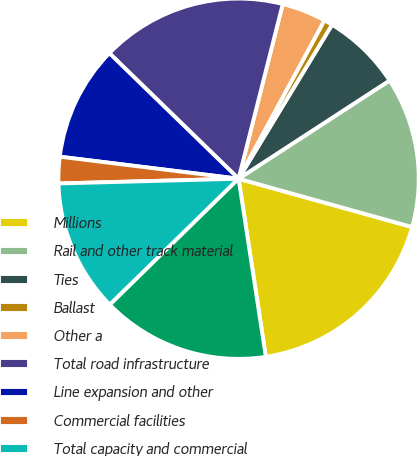Convert chart. <chart><loc_0><loc_0><loc_500><loc_500><pie_chart><fcel>Millions<fcel>Rail and other track material<fcel>Ties<fcel>Ballast<fcel>Other a<fcel>Total road infrastructure<fcel>Line expansion and other<fcel>Commercial facilities<fcel>Total capacity and commercial<fcel>Locomotives and freight cars b<nl><fcel>18.26%<fcel>13.5%<fcel>7.14%<fcel>0.78%<fcel>3.96%<fcel>16.67%<fcel>10.32%<fcel>2.37%<fcel>11.91%<fcel>15.09%<nl></chart> 